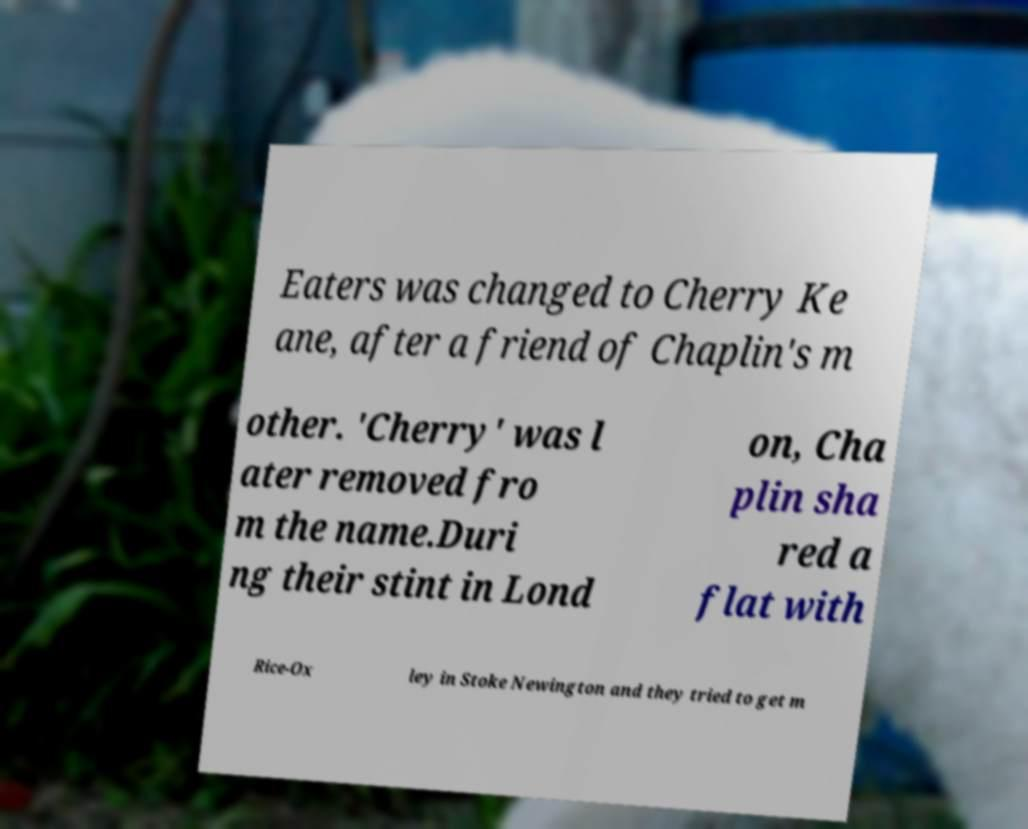I need the written content from this picture converted into text. Can you do that? Eaters was changed to Cherry Ke ane, after a friend of Chaplin's m other. 'Cherry' was l ater removed fro m the name.Duri ng their stint in Lond on, Cha plin sha red a flat with Rice-Ox ley in Stoke Newington and they tried to get m 